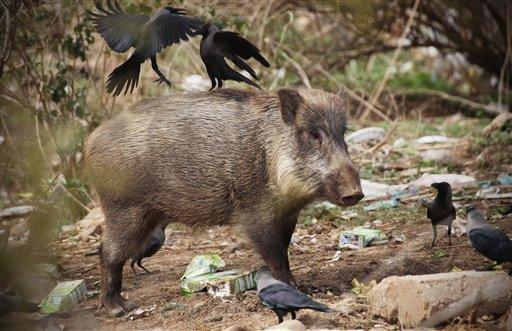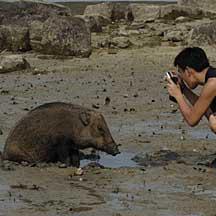The first image is the image on the left, the second image is the image on the right. Analyze the images presented: Is the assertion "An image shows at least one wild pig in the mud." valid? Answer yes or no. Yes. The first image is the image on the left, the second image is the image on the right. Analyze the images presented: Is the assertion "At least one wild animal is wallowing in the mud." valid? Answer yes or no. Yes. 